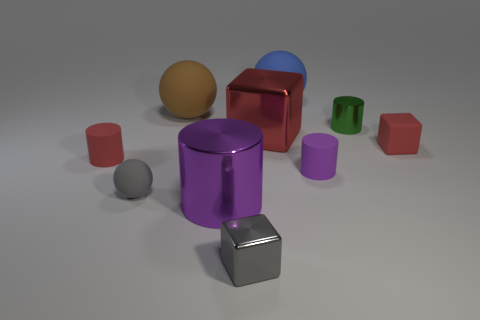Is the number of blue rubber spheres that are in front of the large blue rubber object greater than the number of metal cubes?
Offer a very short reply. No. How many other objects are there of the same color as the matte block?
Provide a short and direct response. 2. There is a purple matte object that is the same size as the gray ball; what shape is it?
Ensure brevity in your answer.  Cylinder. There is a blue sphere that is to the left of the red object that is on the right side of the red metallic block; how many tiny metallic cylinders are right of it?
Your answer should be compact. 1. How many matte things are blue balls or small red cylinders?
Your answer should be compact. 2. What color is the tiny cylinder that is on the left side of the green thing and on the right side of the big brown thing?
Provide a succinct answer. Purple. There is a purple object on the left side of the blue ball; does it have the same size as the big cube?
Make the answer very short. Yes. How many objects are red blocks that are in front of the large block or brown rubber things?
Offer a very short reply. 2. Is there a cyan shiny cube that has the same size as the red metal object?
Offer a terse response. No. What material is the red object that is the same size as the brown sphere?
Provide a short and direct response. Metal. 